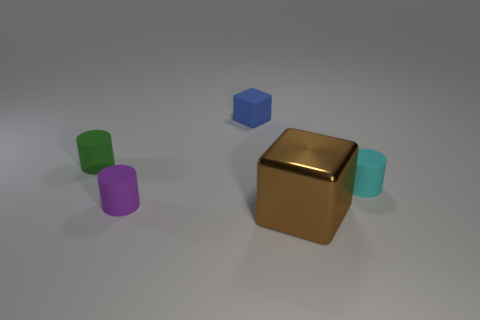Add 5 large purple blocks. How many objects exist? 10 Subtract all cubes. How many objects are left? 3 Subtract all small yellow metal cubes. Subtract all tiny cubes. How many objects are left? 4 Add 1 small things. How many small things are left? 5 Add 4 small rubber cylinders. How many small rubber cylinders exist? 7 Subtract 0 red cylinders. How many objects are left? 5 